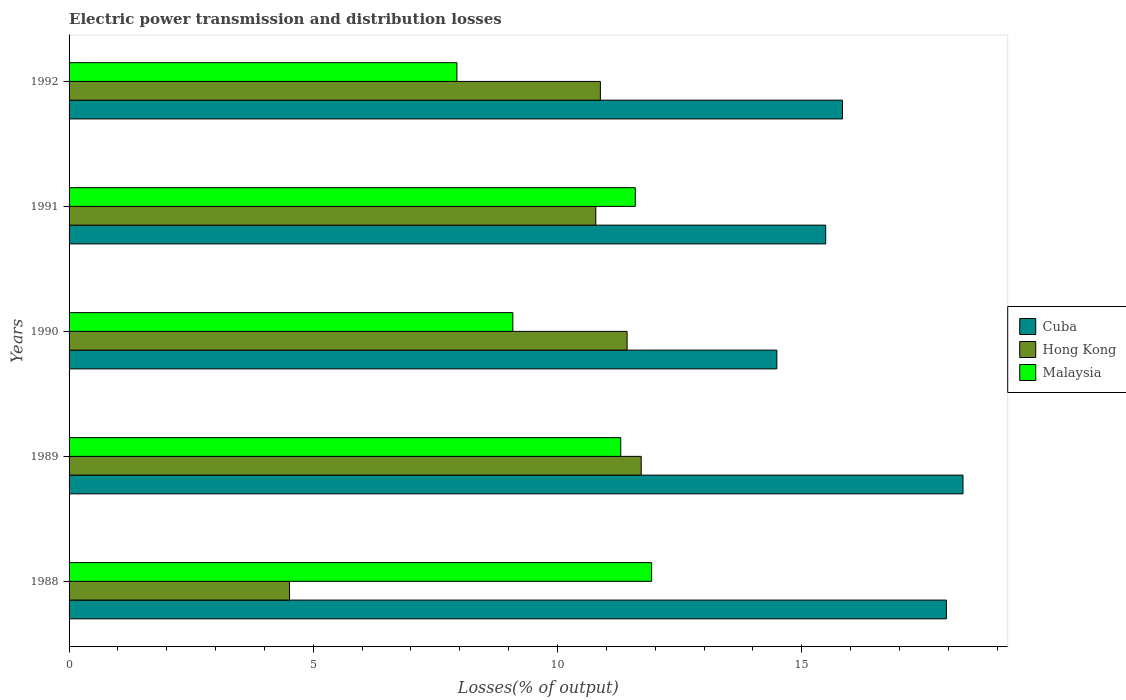How many groups of bars are there?
Make the answer very short. 5. Are the number of bars per tick equal to the number of legend labels?
Keep it short and to the point. Yes. How many bars are there on the 3rd tick from the top?
Your response must be concise. 3. What is the label of the 1st group of bars from the top?
Offer a very short reply. 1992. In how many cases, is the number of bars for a given year not equal to the number of legend labels?
Provide a succinct answer. 0. What is the electric power transmission and distribution losses in Hong Kong in 1988?
Make the answer very short. 4.51. Across all years, what is the maximum electric power transmission and distribution losses in Hong Kong?
Keep it short and to the point. 11.71. Across all years, what is the minimum electric power transmission and distribution losses in Hong Kong?
Your response must be concise. 4.51. In which year was the electric power transmission and distribution losses in Malaysia maximum?
Offer a terse response. 1988. In which year was the electric power transmission and distribution losses in Cuba minimum?
Provide a succinct answer. 1990. What is the total electric power transmission and distribution losses in Malaysia in the graph?
Offer a terse response. 51.84. What is the difference between the electric power transmission and distribution losses in Malaysia in 1988 and that in 1991?
Provide a short and direct response. 0.33. What is the difference between the electric power transmission and distribution losses in Hong Kong in 1990 and the electric power transmission and distribution losses in Malaysia in 1991?
Offer a terse response. -0.17. What is the average electric power transmission and distribution losses in Cuba per year?
Offer a terse response. 16.42. In the year 1988, what is the difference between the electric power transmission and distribution losses in Hong Kong and electric power transmission and distribution losses in Malaysia?
Give a very brief answer. -7.41. In how many years, is the electric power transmission and distribution losses in Hong Kong greater than 18 %?
Provide a short and direct response. 0. What is the ratio of the electric power transmission and distribution losses in Cuba in 1990 to that in 1991?
Ensure brevity in your answer.  0.94. Is the electric power transmission and distribution losses in Cuba in 1988 less than that in 1989?
Give a very brief answer. Yes. What is the difference between the highest and the second highest electric power transmission and distribution losses in Cuba?
Make the answer very short. 0.34. What is the difference between the highest and the lowest electric power transmission and distribution losses in Hong Kong?
Your response must be concise. 7.2. In how many years, is the electric power transmission and distribution losses in Cuba greater than the average electric power transmission and distribution losses in Cuba taken over all years?
Give a very brief answer. 2. Is the sum of the electric power transmission and distribution losses in Hong Kong in 1991 and 1992 greater than the maximum electric power transmission and distribution losses in Malaysia across all years?
Provide a succinct answer. Yes. What does the 1st bar from the top in 1990 represents?
Keep it short and to the point. Malaysia. What does the 1st bar from the bottom in 1992 represents?
Your answer should be very brief. Cuba. Is it the case that in every year, the sum of the electric power transmission and distribution losses in Cuba and electric power transmission and distribution losses in Hong Kong is greater than the electric power transmission and distribution losses in Malaysia?
Provide a short and direct response. Yes. How many bars are there?
Provide a short and direct response. 15. What is the difference between two consecutive major ticks on the X-axis?
Your answer should be very brief. 5. Are the values on the major ticks of X-axis written in scientific E-notation?
Offer a terse response. No. Does the graph contain grids?
Your answer should be compact. No. How many legend labels are there?
Give a very brief answer. 3. What is the title of the graph?
Make the answer very short. Electric power transmission and distribution losses. What is the label or title of the X-axis?
Your response must be concise. Losses(% of output). What is the label or title of the Y-axis?
Give a very brief answer. Years. What is the Losses(% of output) of Cuba in 1988?
Make the answer very short. 17.96. What is the Losses(% of output) in Hong Kong in 1988?
Ensure brevity in your answer.  4.51. What is the Losses(% of output) in Malaysia in 1988?
Provide a succinct answer. 11.93. What is the Losses(% of output) of Cuba in 1989?
Keep it short and to the point. 18.3. What is the Losses(% of output) in Hong Kong in 1989?
Your answer should be very brief. 11.71. What is the Losses(% of output) of Malaysia in 1989?
Provide a succinct answer. 11.29. What is the Losses(% of output) in Cuba in 1990?
Ensure brevity in your answer.  14.49. What is the Losses(% of output) in Hong Kong in 1990?
Give a very brief answer. 11.42. What is the Losses(% of output) of Malaysia in 1990?
Your answer should be compact. 9.08. What is the Losses(% of output) of Cuba in 1991?
Keep it short and to the point. 15.49. What is the Losses(% of output) in Hong Kong in 1991?
Keep it short and to the point. 10.78. What is the Losses(% of output) in Malaysia in 1991?
Ensure brevity in your answer.  11.59. What is the Losses(% of output) of Cuba in 1992?
Make the answer very short. 15.83. What is the Losses(% of output) in Hong Kong in 1992?
Keep it short and to the point. 10.88. What is the Losses(% of output) of Malaysia in 1992?
Make the answer very short. 7.94. Across all years, what is the maximum Losses(% of output) in Cuba?
Your answer should be very brief. 18.3. Across all years, what is the maximum Losses(% of output) of Hong Kong?
Offer a very short reply. 11.71. Across all years, what is the maximum Losses(% of output) in Malaysia?
Your answer should be very brief. 11.93. Across all years, what is the minimum Losses(% of output) of Cuba?
Offer a very short reply. 14.49. Across all years, what is the minimum Losses(% of output) in Hong Kong?
Your response must be concise. 4.51. Across all years, what is the minimum Losses(% of output) of Malaysia?
Make the answer very short. 7.94. What is the total Losses(% of output) of Cuba in the graph?
Make the answer very short. 82.08. What is the total Losses(% of output) in Hong Kong in the graph?
Give a very brief answer. 49.31. What is the total Losses(% of output) in Malaysia in the graph?
Make the answer very short. 51.84. What is the difference between the Losses(% of output) of Cuba in 1988 and that in 1989?
Your answer should be compact. -0.34. What is the difference between the Losses(% of output) in Hong Kong in 1988 and that in 1989?
Offer a terse response. -7.2. What is the difference between the Losses(% of output) of Malaysia in 1988 and that in 1989?
Make the answer very short. 0.63. What is the difference between the Losses(% of output) of Cuba in 1988 and that in 1990?
Give a very brief answer. 3.47. What is the difference between the Losses(% of output) of Hong Kong in 1988 and that in 1990?
Your answer should be compact. -6.91. What is the difference between the Losses(% of output) in Malaysia in 1988 and that in 1990?
Your answer should be compact. 2.84. What is the difference between the Losses(% of output) in Cuba in 1988 and that in 1991?
Ensure brevity in your answer.  2.47. What is the difference between the Losses(% of output) of Hong Kong in 1988 and that in 1991?
Keep it short and to the point. -6.27. What is the difference between the Losses(% of output) of Malaysia in 1988 and that in 1991?
Your answer should be compact. 0.33. What is the difference between the Losses(% of output) of Cuba in 1988 and that in 1992?
Your response must be concise. 2.13. What is the difference between the Losses(% of output) of Hong Kong in 1988 and that in 1992?
Provide a succinct answer. -6.36. What is the difference between the Losses(% of output) in Malaysia in 1988 and that in 1992?
Make the answer very short. 3.99. What is the difference between the Losses(% of output) of Cuba in 1989 and that in 1990?
Offer a terse response. 3.81. What is the difference between the Losses(% of output) of Hong Kong in 1989 and that in 1990?
Your response must be concise. 0.29. What is the difference between the Losses(% of output) in Malaysia in 1989 and that in 1990?
Provide a short and direct response. 2.21. What is the difference between the Losses(% of output) in Cuba in 1989 and that in 1991?
Keep it short and to the point. 2.81. What is the difference between the Losses(% of output) in Malaysia in 1989 and that in 1991?
Your response must be concise. -0.3. What is the difference between the Losses(% of output) in Cuba in 1989 and that in 1992?
Provide a short and direct response. 2.47. What is the difference between the Losses(% of output) of Hong Kong in 1989 and that in 1992?
Give a very brief answer. 0.84. What is the difference between the Losses(% of output) of Malaysia in 1989 and that in 1992?
Your answer should be very brief. 3.35. What is the difference between the Losses(% of output) in Cuba in 1990 and that in 1991?
Keep it short and to the point. -1. What is the difference between the Losses(% of output) in Hong Kong in 1990 and that in 1991?
Make the answer very short. 0.64. What is the difference between the Losses(% of output) in Malaysia in 1990 and that in 1991?
Give a very brief answer. -2.51. What is the difference between the Losses(% of output) of Cuba in 1990 and that in 1992?
Give a very brief answer. -1.34. What is the difference between the Losses(% of output) of Hong Kong in 1990 and that in 1992?
Your answer should be very brief. 0.55. What is the difference between the Losses(% of output) of Malaysia in 1990 and that in 1992?
Ensure brevity in your answer.  1.14. What is the difference between the Losses(% of output) in Cuba in 1991 and that in 1992?
Your response must be concise. -0.34. What is the difference between the Losses(% of output) of Hong Kong in 1991 and that in 1992?
Ensure brevity in your answer.  -0.09. What is the difference between the Losses(% of output) in Malaysia in 1991 and that in 1992?
Ensure brevity in your answer.  3.65. What is the difference between the Losses(% of output) of Cuba in 1988 and the Losses(% of output) of Hong Kong in 1989?
Your response must be concise. 6.25. What is the difference between the Losses(% of output) of Cuba in 1988 and the Losses(% of output) of Malaysia in 1989?
Make the answer very short. 6.67. What is the difference between the Losses(% of output) of Hong Kong in 1988 and the Losses(% of output) of Malaysia in 1989?
Provide a short and direct response. -6.78. What is the difference between the Losses(% of output) in Cuba in 1988 and the Losses(% of output) in Hong Kong in 1990?
Ensure brevity in your answer.  6.54. What is the difference between the Losses(% of output) in Cuba in 1988 and the Losses(% of output) in Malaysia in 1990?
Offer a very short reply. 8.88. What is the difference between the Losses(% of output) of Hong Kong in 1988 and the Losses(% of output) of Malaysia in 1990?
Ensure brevity in your answer.  -4.57. What is the difference between the Losses(% of output) of Cuba in 1988 and the Losses(% of output) of Hong Kong in 1991?
Ensure brevity in your answer.  7.18. What is the difference between the Losses(% of output) of Cuba in 1988 and the Losses(% of output) of Malaysia in 1991?
Your answer should be very brief. 6.37. What is the difference between the Losses(% of output) in Hong Kong in 1988 and the Losses(% of output) in Malaysia in 1991?
Offer a very short reply. -7.08. What is the difference between the Losses(% of output) of Cuba in 1988 and the Losses(% of output) of Hong Kong in 1992?
Keep it short and to the point. 7.08. What is the difference between the Losses(% of output) of Cuba in 1988 and the Losses(% of output) of Malaysia in 1992?
Give a very brief answer. 10.02. What is the difference between the Losses(% of output) of Hong Kong in 1988 and the Losses(% of output) of Malaysia in 1992?
Your answer should be very brief. -3.43. What is the difference between the Losses(% of output) in Cuba in 1989 and the Losses(% of output) in Hong Kong in 1990?
Offer a terse response. 6.88. What is the difference between the Losses(% of output) of Cuba in 1989 and the Losses(% of output) of Malaysia in 1990?
Your answer should be very brief. 9.22. What is the difference between the Losses(% of output) of Hong Kong in 1989 and the Losses(% of output) of Malaysia in 1990?
Offer a very short reply. 2.63. What is the difference between the Losses(% of output) in Cuba in 1989 and the Losses(% of output) in Hong Kong in 1991?
Offer a terse response. 7.52. What is the difference between the Losses(% of output) of Cuba in 1989 and the Losses(% of output) of Malaysia in 1991?
Ensure brevity in your answer.  6.71. What is the difference between the Losses(% of output) of Hong Kong in 1989 and the Losses(% of output) of Malaysia in 1991?
Offer a terse response. 0.12. What is the difference between the Losses(% of output) in Cuba in 1989 and the Losses(% of output) in Hong Kong in 1992?
Offer a terse response. 7.42. What is the difference between the Losses(% of output) of Cuba in 1989 and the Losses(% of output) of Malaysia in 1992?
Give a very brief answer. 10.36. What is the difference between the Losses(% of output) in Hong Kong in 1989 and the Losses(% of output) in Malaysia in 1992?
Your response must be concise. 3.77. What is the difference between the Losses(% of output) of Cuba in 1990 and the Losses(% of output) of Hong Kong in 1991?
Your response must be concise. 3.71. What is the difference between the Losses(% of output) in Cuba in 1990 and the Losses(% of output) in Malaysia in 1991?
Offer a terse response. 2.9. What is the difference between the Losses(% of output) of Hong Kong in 1990 and the Losses(% of output) of Malaysia in 1991?
Make the answer very short. -0.17. What is the difference between the Losses(% of output) of Cuba in 1990 and the Losses(% of output) of Hong Kong in 1992?
Ensure brevity in your answer.  3.61. What is the difference between the Losses(% of output) in Cuba in 1990 and the Losses(% of output) in Malaysia in 1992?
Your response must be concise. 6.55. What is the difference between the Losses(% of output) of Hong Kong in 1990 and the Losses(% of output) of Malaysia in 1992?
Provide a succinct answer. 3.48. What is the difference between the Losses(% of output) in Cuba in 1991 and the Losses(% of output) in Hong Kong in 1992?
Offer a very short reply. 4.61. What is the difference between the Losses(% of output) in Cuba in 1991 and the Losses(% of output) in Malaysia in 1992?
Make the answer very short. 7.55. What is the difference between the Losses(% of output) of Hong Kong in 1991 and the Losses(% of output) of Malaysia in 1992?
Provide a succinct answer. 2.84. What is the average Losses(% of output) of Cuba per year?
Give a very brief answer. 16.42. What is the average Losses(% of output) of Hong Kong per year?
Your response must be concise. 9.86. What is the average Losses(% of output) in Malaysia per year?
Ensure brevity in your answer.  10.37. In the year 1988, what is the difference between the Losses(% of output) of Cuba and Losses(% of output) of Hong Kong?
Your answer should be compact. 13.45. In the year 1988, what is the difference between the Losses(% of output) of Cuba and Losses(% of output) of Malaysia?
Offer a terse response. 6.04. In the year 1988, what is the difference between the Losses(% of output) of Hong Kong and Losses(% of output) of Malaysia?
Make the answer very short. -7.41. In the year 1989, what is the difference between the Losses(% of output) of Cuba and Losses(% of output) of Hong Kong?
Give a very brief answer. 6.59. In the year 1989, what is the difference between the Losses(% of output) in Cuba and Losses(% of output) in Malaysia?
Your response must be concise. 7.01. In the year 1989, what is the difference between the Losses(% of output) in Hong Kong and Losses(% of output) in Malaysia?
Offer a very short reply. 0.42. In the year 1990, what is the difference between the Losses(% of output) of Cuba and Losses(% of output) of Hong Kong?
Your response must be concise. 3.07. In the year 1990, what is the difference between the Losses(% of output) of Cuba and Losses(% of output) of Malaysia?
Give a very brief answer. 5.41. In the year 1990, what is the difference between the Losses(% of output) in Hong Kong and Losses(% of output) in Malaysia?
Ensure brevity in your answer.  2.34. In the year 1991, what is the difference between the Losses(% of output) of Cuba and Losses(% of output) of Hong Kong?
Keep it short and to the point. 4.71. In the year 1991, what is the difference between the Losses(% of output) in Cuba and Losses(% of output) in Malaysia?
Give a very brief answer. 3.9. In the year 1991, what is the difference between the Losses(% of output) in Hong Kong and Losses(% of output) in Malaysia?
Offer a terse response. -0.81. In the year 1992, what is the difference between the Losses(% of output) of Cuba and Losses(% of output) of Hong Kong?
Offer a very short reply. 4.96. In the year 1992, what is the difference between the Losses(% of output) of Cuba and Losses(% of output) of Malaysia?
Your response must be concise. 7.89. In the year 1992, what is the difference between the Losses(% of output) in Hong Kong and Losses(% of output) in Malaysia?
Your answer should be compact. 2.94. What is the ratio of the Losses(% of output) in Cuba in 1988 to that in 1989?
Your answer should be compact. 0.98. What is the ratio of the Losses(% of output) in Hong Kong in 1988 to that in 1989?
Provide a short and direct response. 0.39. What is the ratio of the Losses(% of output) in Malaysia in 1988 to that in 1989?
Ensure brevity in your answer.  1.06. What is the ratio of the Losses(% of output) of Cuba in 1988 to that in 1990?
Give a very brief answer. 1.24. What is the ratio of the Losses(% of output) in Hong Kong in 1988 to that in 1990?
Make the answer very short. 0.4. What is the ratio of the Losses(% of output) of Malaysia in 1988 to that in 1990?
Offer a very short reply. 1.31. What is the ratio of the Losses(% of output) of Cuba in 1988 to that in 1991?
Give a very brief answer. 1.16. What is the ratio of the Losses(% of output) of Hong Kong in 1988 to that in 1991?
Give a very brief answer. 0.42. What is the ratio of the Losses(% of output) in Malaysia in 1988 to that in 1991?
Provide a succinct answer. 1.03. What is the ratio of the Losses(% of output) of Cuba in 1988 to that in 1992?
Make the answer very short. 1.13. What is the ratio of the Losses(% of output) in Hong Kong in 1988 to that in 1992?
Give a very brief answer. 0.41. What is the ratio of the Losses(% of output) of Malaysia in 1988 to that in 1992?
Ensure brevity in your answer.  1.5. What is the ratio of the Losses(% of output) in Cuba in 1989 to that in 1990?
Your answer should be compact. 1.26. What is the ratio of the Losses(% of output) in Hong Kong in 1989 to that in 1990?
Ensure brevity in your answer.  1.03. What is the ratio of the Losses(% of output) of Malaysia in 1989 to that in 1990?
Your response must be concise. 1.24. What is the ratio of the Losses(% of output) in Cuba in 1989 to that in 1991?
Ensure brevity in your answer.  1.18. What is the ratio of the Losses(% of output) of Hong Kong in 1989 to that in 1991?
Provide a short and direct response. 1.09. What is the ratio of the Losses(% of output) in Malaysia in 1989 to that in 1991?
Ensure brevity in your answer.  0.97. What is the ratio of the Losses(% of output) in Cuba in 1989 to that in 1992?
Offer a very short reply. 1.16. What is the ratio of the Losses(% of output) of Malaysia in 1989 to that in 1992?
Your answer should be very brief. 1.42. What is the ratio of the Losses(% of output) of Cuba in 1990 to that in 1991?
Your response must be concise. 0.94. What is the ratio of the Losses(% of output) in Hong Kong in 1990 to that in 1991?
Your answer should be compact. 1.06. What is the ratio of the Losses(% of output) in Malaysia in 1990 to that in 1991?
Provide a succinct answer. 0.78. What is the ratio of the Losses(% of output) in Cuba in 1990 to that in 1992?
Your answer should be compact. 0.92. What is the ratio of the Losses(% of output) of Hong Kong in 1990 to that in 1992?
Offer a terse response. 1.05. What is the ratio of the Losses(% of output) of Malaysia in 1990 to that in 1992?
Your response must be concise. 1.14. What is the ratio of the Losses(% of output) in Cuba in 1991 to that in 1992?
Provide a short and direct response. 0.98. What is the ratio of the Losses(% of output) of Hong Kong in 1991 to that in 1992?
Provide a succinct answer. 0.99. What is the ratio of the Losses(% of output) in Malaysia in 1991 to that in 1992?
Keep it short and to the point. 1.46. What is the difference between the highest and the second highest Losses(% of output) of Cuba?
Offer a very short reply. 0.34. What is the difference between the highest and the second highest Losses(% of output) in Hong Kong?
Your answer should be very brief. 0.29. What is the difference between the highest and the second highest Losses(% of output) in Malaysia?
Ensure brevity in your answer.  0.33. What is the difference between the highest and the lowest Losses(% of output) in Cuba?
Your response must be concise. 3.81. What is the difference between the highest and the lowest Losses(% of output) of Hong Kong?
Provide a short and direct response. 7.2. What is the difference between the highest and the lowest Losses(% of output) of Malaysia?
Your answer should be compact. 3.99. 